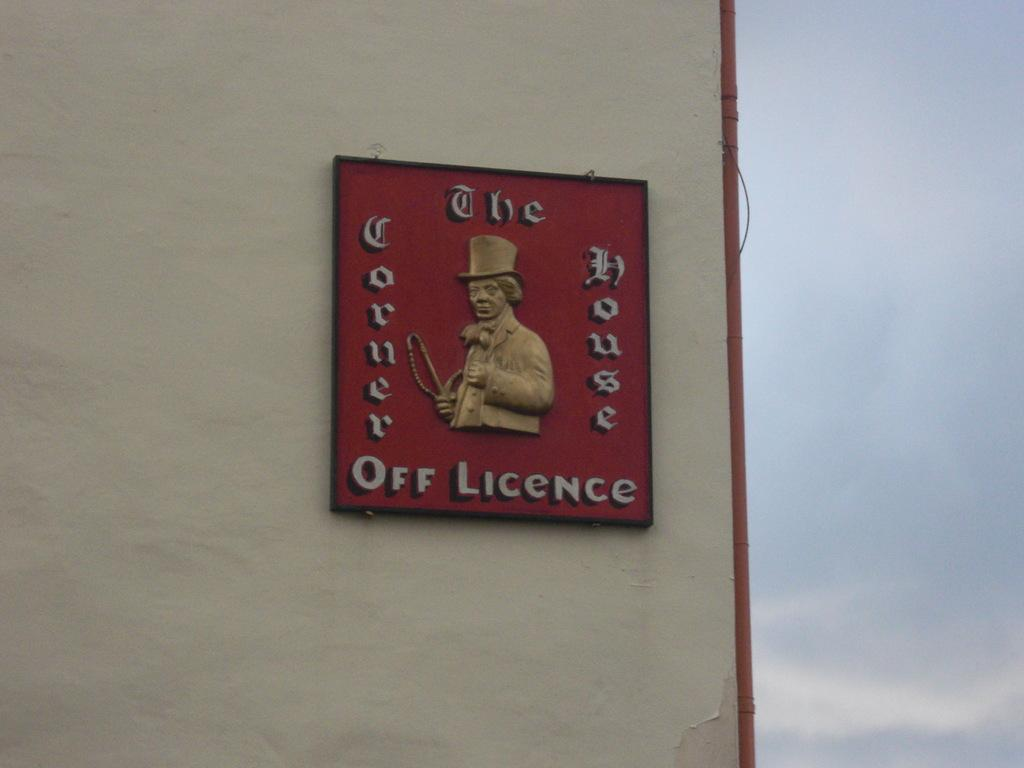<image>
Render a clear and concise summary of the photo. A red sign says off licence on the bottom. 